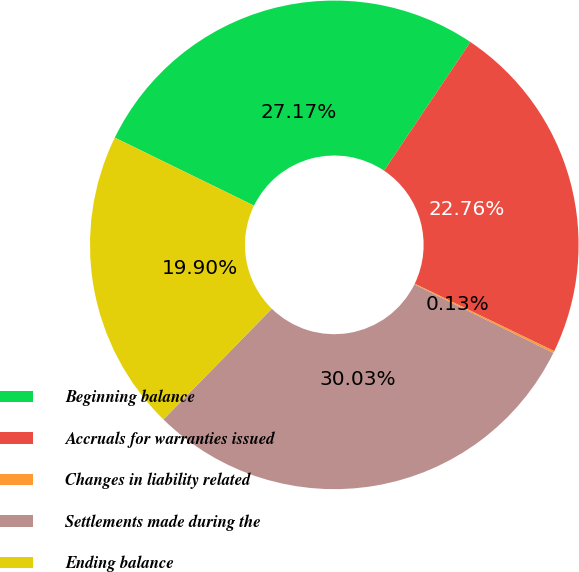Convert chart to OTSL. <chart><loc_0><loc_0><loc_500><loc_500><pie_chart><fcel>Beginning balance<fcel>Accruals for warranties issued<fcel>Changes in liability related<fcel>Settlements made during the<fcel>Ending balance<nl><fcel>27.17%<fcel>22.76%<fcel>0.13%<fcel>30.03%<fcel>19.9%<nl></chart> 